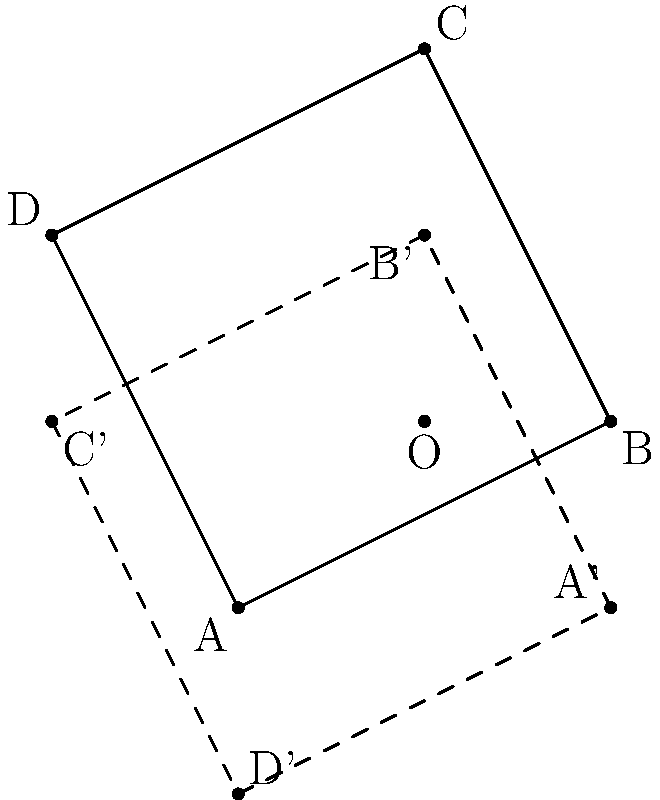A map of Civil War battle sites is represented by the quadrilateral ABCD. If this map is rotated 90° counterclockwise around point O (1,1), what will be the coordinates of point A' (the rotated position of A)? To find the coordinates of A' after rotating point A (0,0) by 90° counterclockwise around O (1,1), we can follow these steps:

1) First, we need to use the rotation formula for a point (x,y) around a center (a,b) by an angle θ:
   x' = (x-a)cosθ - (y-b)sinθ + a
   y' = (x-a)sinθ + (y-b)cosθ + b

2) In our case:
   x = 0, y = 0 (coordinates of A)
   a = 1, b = 1 (coordinates of O)
   θ = 90° = π/2 radians

3) We know that cos(90°) = 0 and sin(90°) = 1

4) Let's substitute these values into our formula:
   x' = (0-1)cos(90°) - (0-1)sin(90°) + 1
      = (-1)(0) - (-1)(1) + 1
      = 0 + 1 + 1 = 2

   y' = (0-1)sin(90°) + (0-1)cos(90°) + 1
      = (-1)(1) + (-1)(0) + 1
      = -1 + 0 + 1 = 0

5) Therefore, the coordinates of A' after rotation are (2,0).
Answer: (2,0) 